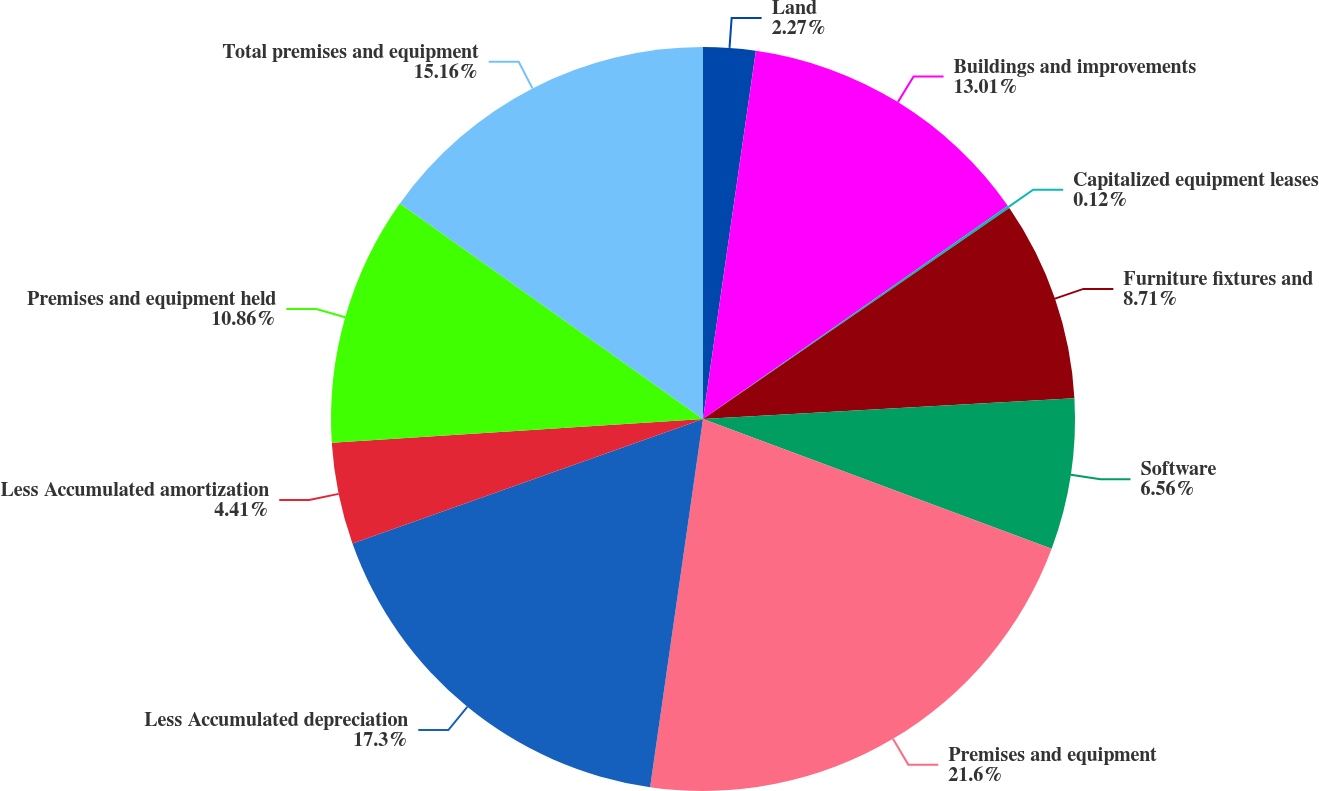<chart> <loc_0><loc_0><loc_500><loc_500><pie_chart><fcel>Land<fcel>Buildings and improvements<fcel>Capitalized equipment leases<fcel>Furniture fixtures and<fcel>Software<fcel>Premises and equipment<fcel>Less Accumulated depreciation<fcel>Less Accumulated amortization<fcel>Premises and equipment held<fcel>Total premises and equipment<nl><fcel>2.27%<fcel>13.01%<fcel>0.12%<fcel>8.71%<fcel>6.56%<fcel>21.6%<fcel>17.3%<fcel>4.41%<fcel>10.86%<fcel>15.16%<nl></chart> 